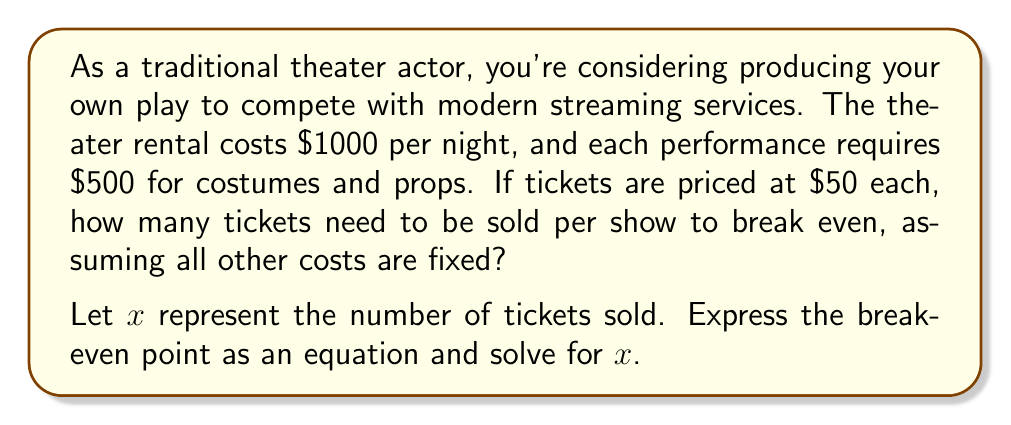Can you solve this math problem? To solve this problem, we need to set up an equation where the total revenue equals the total costs. This is the break-even point.

1) Let's define our variables:
   $x$ = number of tickets sold
   $R$ = Revenue
   $C$ = Costs

2) Revenue equation:
   $R = 50x$ (since each ticket costs $50)

3) Cost equation:
   $C = 1000 + 500 = 1500$ (fixed costs per show)

4) At the break-even point, Revenue = Costs:
   $R = C$
   $50x = 1500$

5) Solve for $x$:
   $$50x = 1500$$
   $$x = \frac{1500}{50}$$
   $$x = 30$$

6) Check:
   Revenue: $50 * 30 = 1500$
   Costs: $1500$
   
   Indeed, at 30 tickets, revenue equals costs.
Answer: The break-even point is 30 tickets. The theater needs to sell 30 tickets per show to cover all costs. 